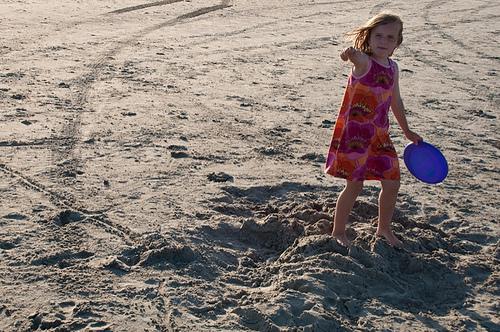What gender are the subjects of this photo?
Concise answer only. Female. Is the girl wearing a summer dress?
Give a very brief answer. Yes. What direction are the shadows facing?
Be succinct. Right. Is the water cold?
Quick response, please. No. What color is the Frisbee?
Concise answer only. Blue. Is this taking place in the summertime?
Keep it brief. Yes. Are the people wet?
Answer briefly. No. What is the blue object called?
Give a very brief answer. Frisbee. Does it seem likely the little girl is going to try to throw the frisbee higher than her own head?
Quick response, please. Yes. 